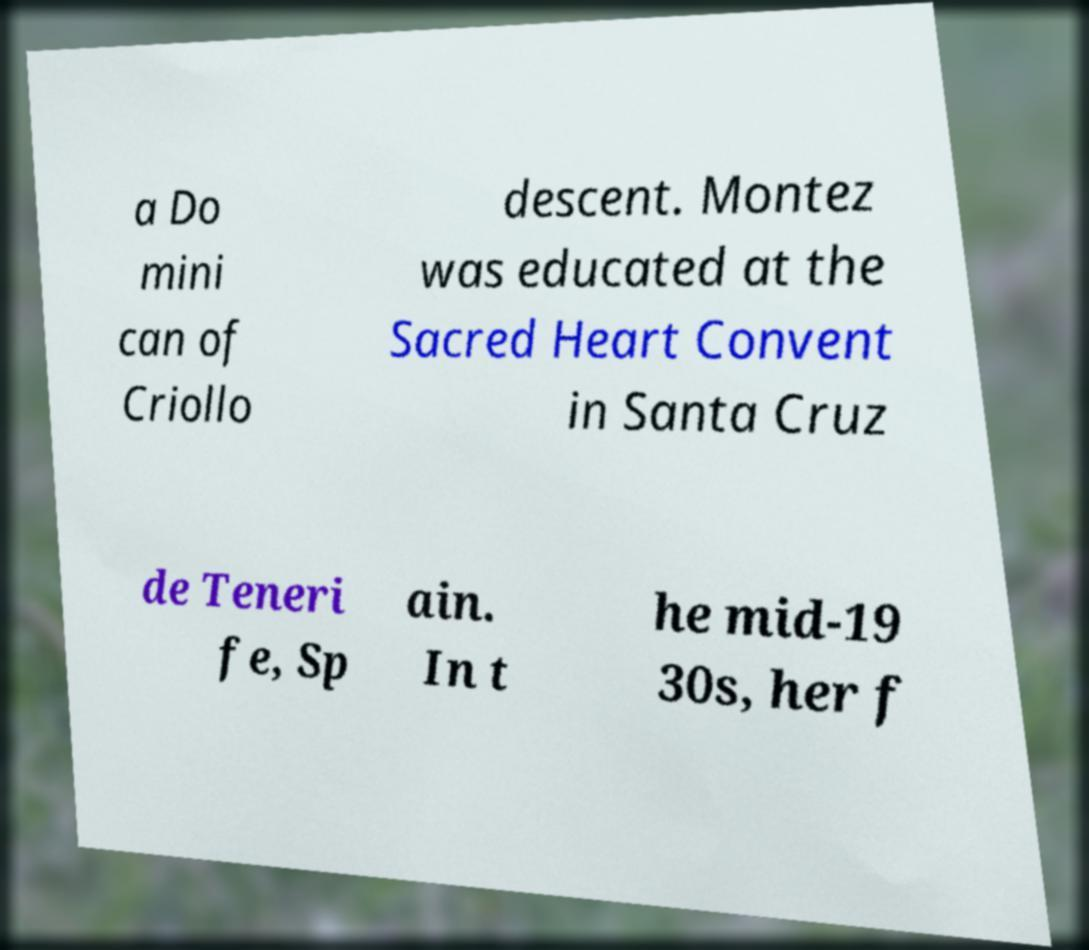Please identify and transcribe the text found in this image. a Do mini can of Criollo descent. Montez was educated at the Sacred Heart Convent in Santa Cruz de Teneri fe, Sp ain. In t he mid-19 30s, her f 